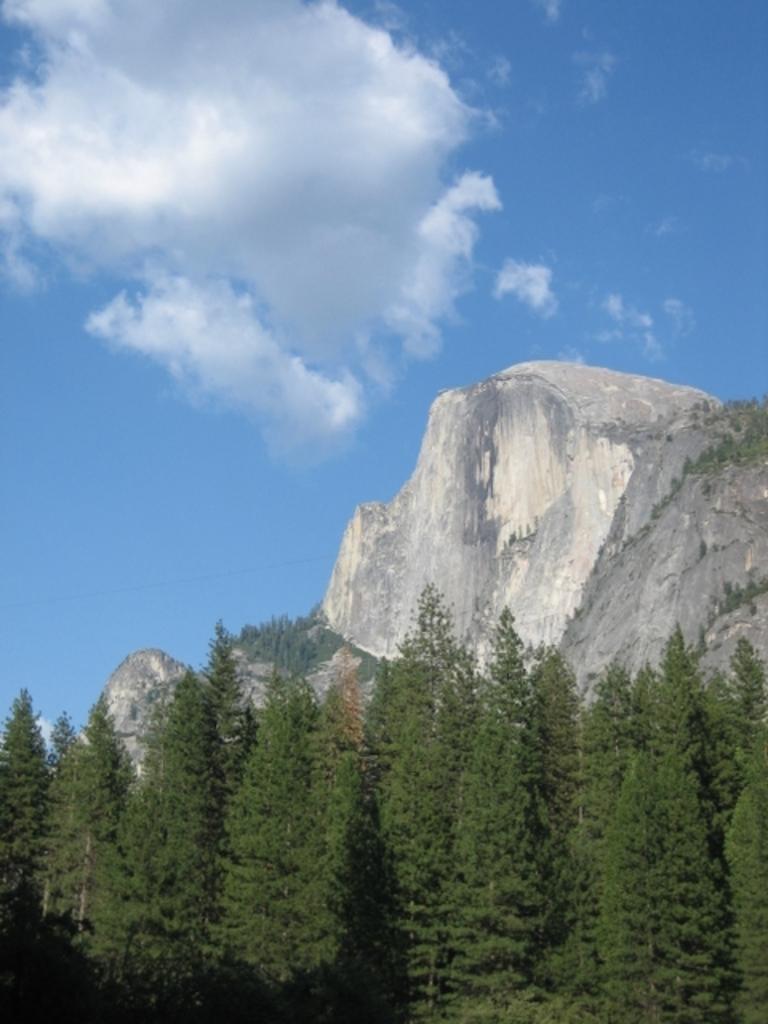How would you summarize this image in a sentence or two? This image consists of many trees. And we can see a mountain. At the top, there are clouds in the sky. 